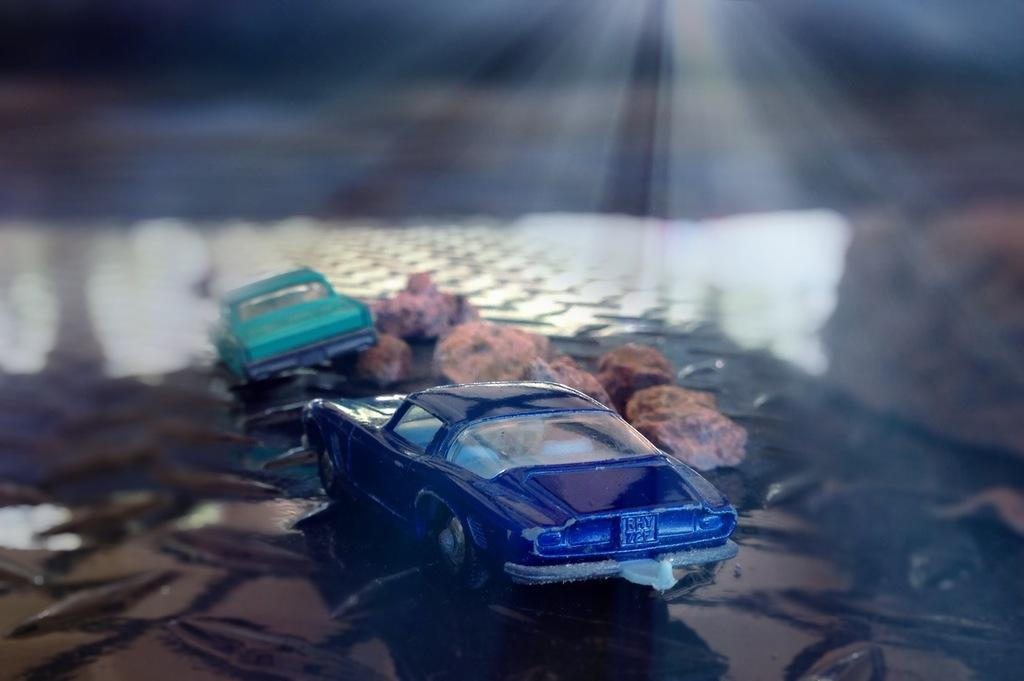What objects are in the center of the image? There are toy cars and stones in the center of the image. Can you describe the toy cars in the image? The toy cars are small, likely made of plastic or metal, and are designed to resemble real cars. What can you tell me about the stones in the image? The stones appear to be small and may be of different shapes and sizes. What type of leather is being used to make the pan in the image? There is no pan present in the image, so it is not possible to determine what type of leather might be used. 